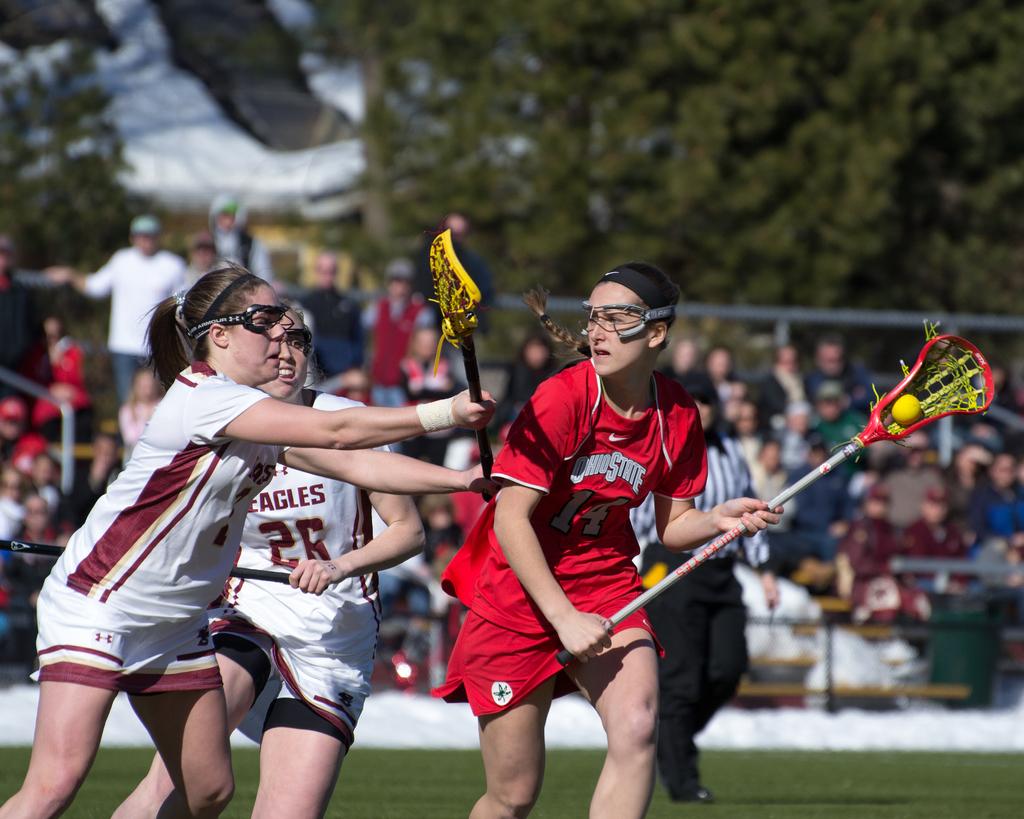Who are the white team?
Keep it short and to the point. Eagles. What number is the girl in red?
Offer a very short reply. 14. 